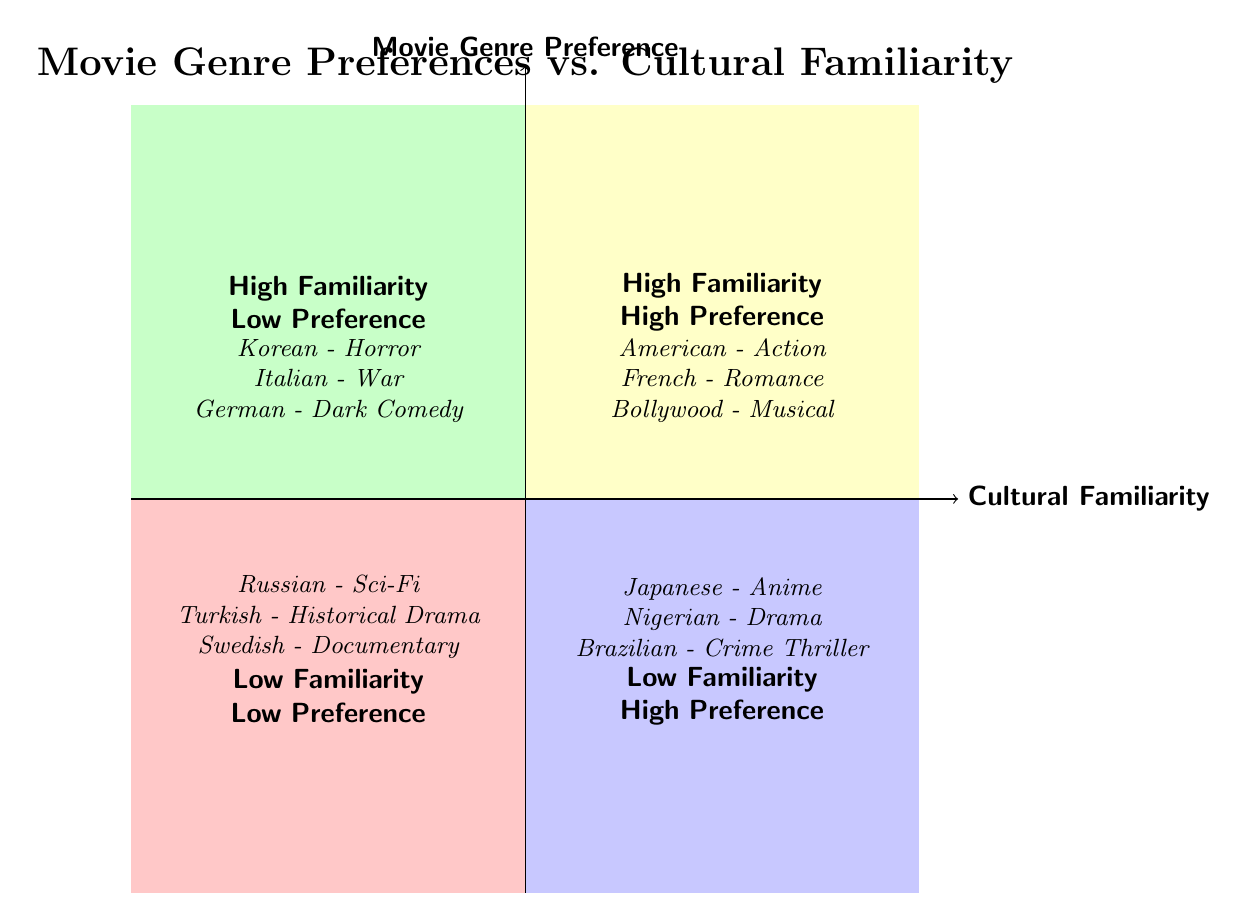What genres are listed under High Cultural Familiarity, High Movie Genre Preference? The quadrant titled "High Cultural Familiarity, High Movie Genre Preference" includes examples such as American - Action, French - Romance, and Bollywood - Musical.
Answer: American - Action, French - Romance, Bollywood - Musical How many examples are in the Low Cultural Familiarity, Low Movie Genre Preference quadrant? In the "Low Cultural Familiarity, Low Movie Genre Preference" quadrant, three examples are provided: Russian - Sci-Fi, Turkish - Historical Drama, and Swedish - Documentary. Thus, there are three examples.
Answer: 3 Which quadrant contains examples from Korean cinema? The examples from Korean cinema, specifically Korean - Horror, are located in the "High Cultural Familiarity, Low Movie Genre Preference" quadrant, as indicated by its classification.
Answer: High Cultural Familiarity, Low Movie Genre Preference What is the defining characteristic of the Low Familiarity, High Preference quadrant? The "Low Familiarity, High Preference" quadrant includes genres from cultures that the viewer may not be very familiar with but still has a preference for those movie genres. Examples like Japanese - Anime showcase this concept.
Answer: Low Familiarity, High Preference How does the number of examples in High Familiarity compare to Low Familiarity quadrants? Both "High Cultural Familiarity, High Movie Genre Preference" and "High Cultural Familiarity, Low Movie Genre Preference" have three examples each, whereas both "Low Cultural Familiarity, High Movie Genre Preference" and "Low Cultural Familiarity, Low Movie Genre Preference" also contain three examples each. Therefore, the number is equal in both categories.
Answer: Equal number of examples 